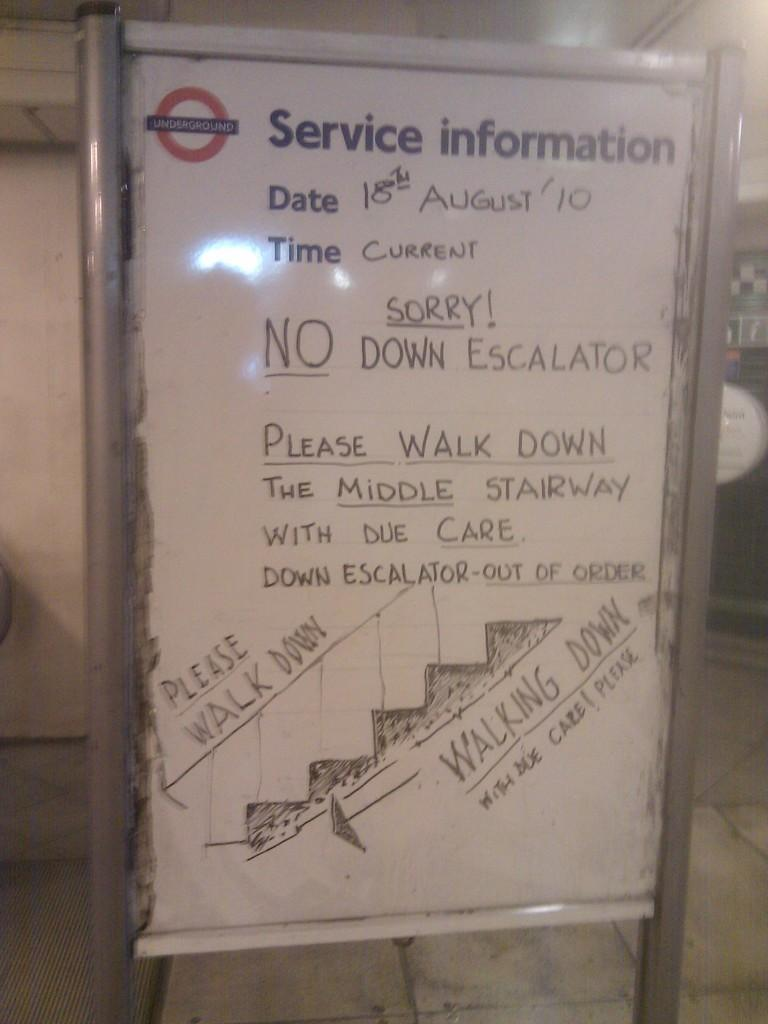<image>
Create a compact narrative representing the image presented. A sign standing on the tile floor with Service Information at the top. 